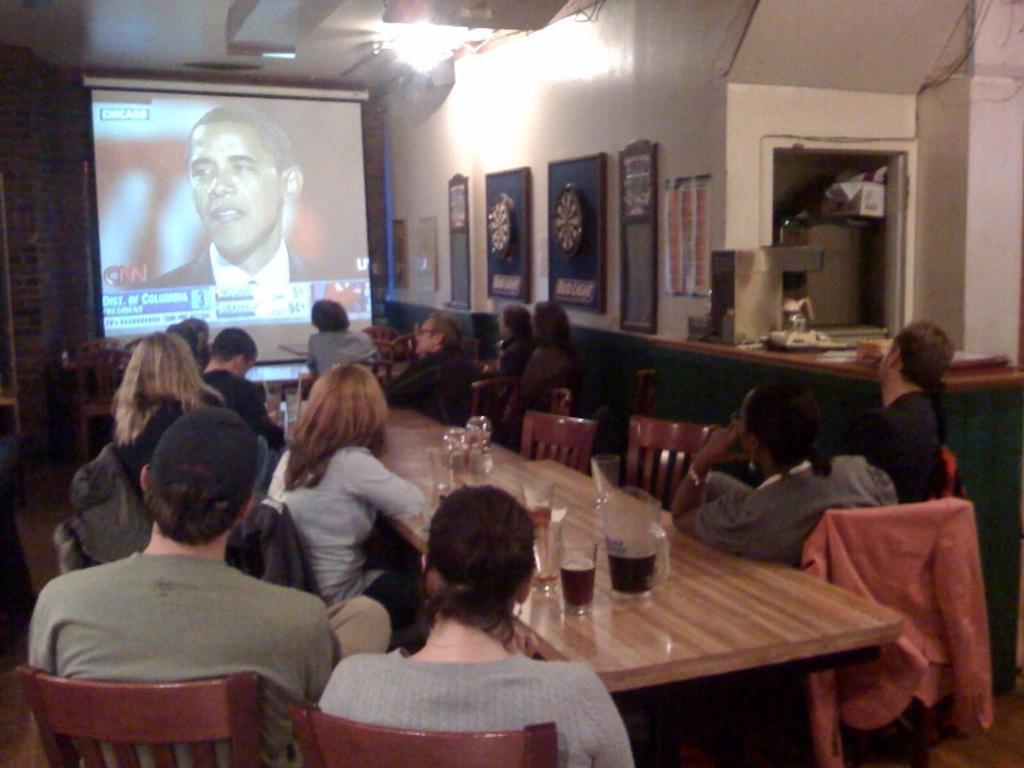Please provide a concise description of this image. Here w ecan see all the p[erosn sistting on chairs infront of a table and on the table we can see glass jars with drink init. here we can see a screen Where we can see frames and poster over a wall. 